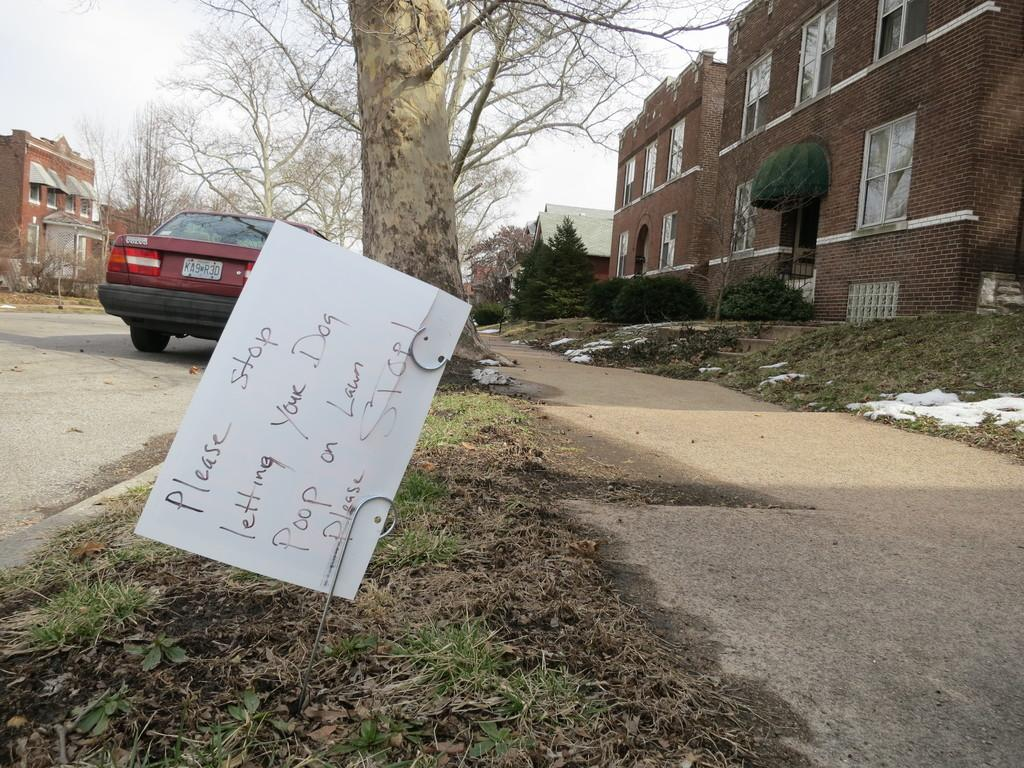What type of structures can be seen in the image? There are buildings in the image. What natural elements are present in the image? There are trees, plants, and grass visible in the image. What mode of transportation can be seen on the road in the image? There is a vehicle on the road in the image. Is there any text present in the image? Yes, there is a card with text in the image. What part of the natural environment is visible in the image? The sky is visible in the image. What type of detail can be seen in the pocket of the person in the image? There is no person present in the image, and therefore no pockets or details to observe. What type of drug is being sold in the image? There is no reference to any drugs or drug sales in the image. 